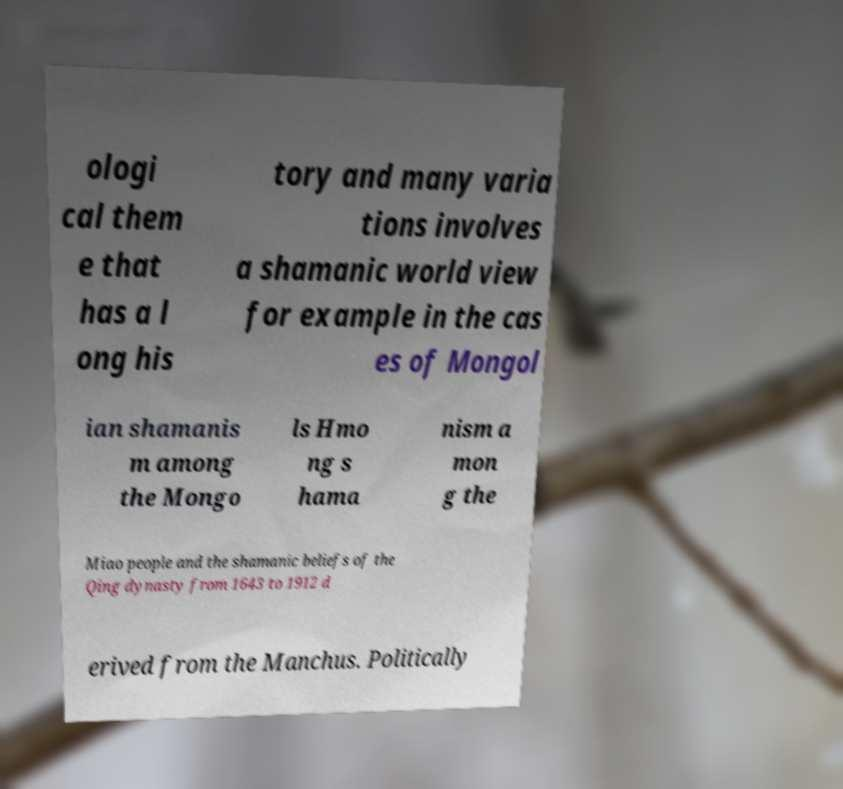Could you assist in decoding the text presented in this image and type it out clearly? ologi cal them e that has a l ong his tory and many varia tions involves a shamanic world view for example in the cas es of Mongol ian shamanis m among the Mongo ls Hmo ng s hama nism a mon g the Miao people and the shamanic beliefs of the Qing dynasty from 1643 to 1912 d erived from the Manchus. Politically 